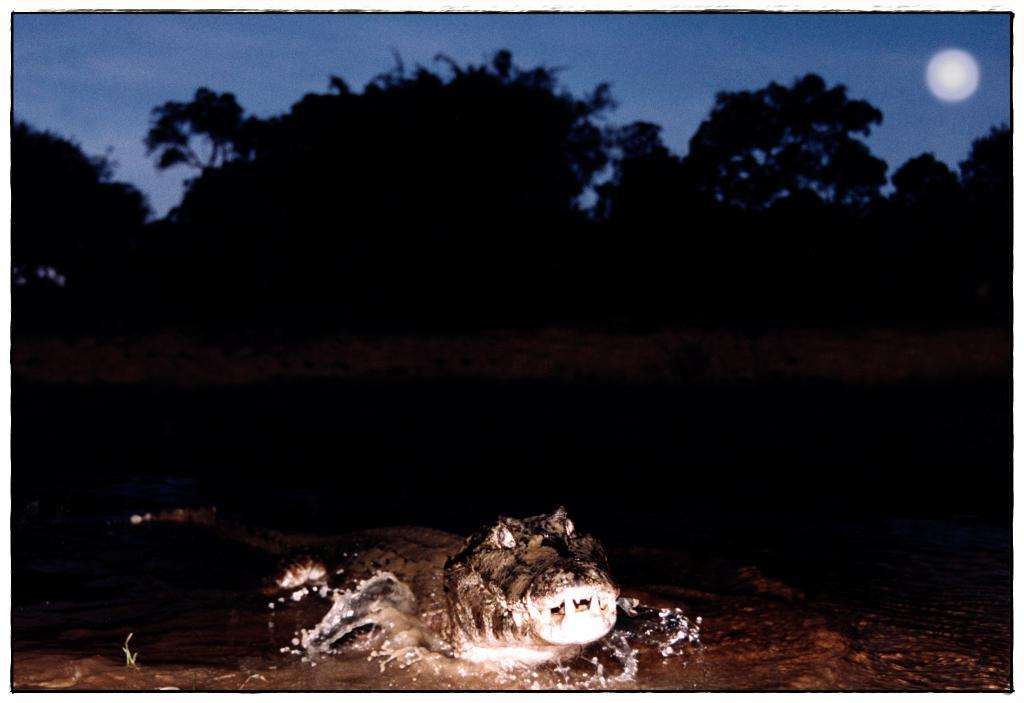What animal is in the water in the center of the image? There is a crocodile in the water in the center of the image. What can be seen in the background of the image? The sky, trees, and the moon are visible in the background of the image. What type of flight is the crocodile taking in the image? The crocodile is not taking a flight in the image; it is in the water. 